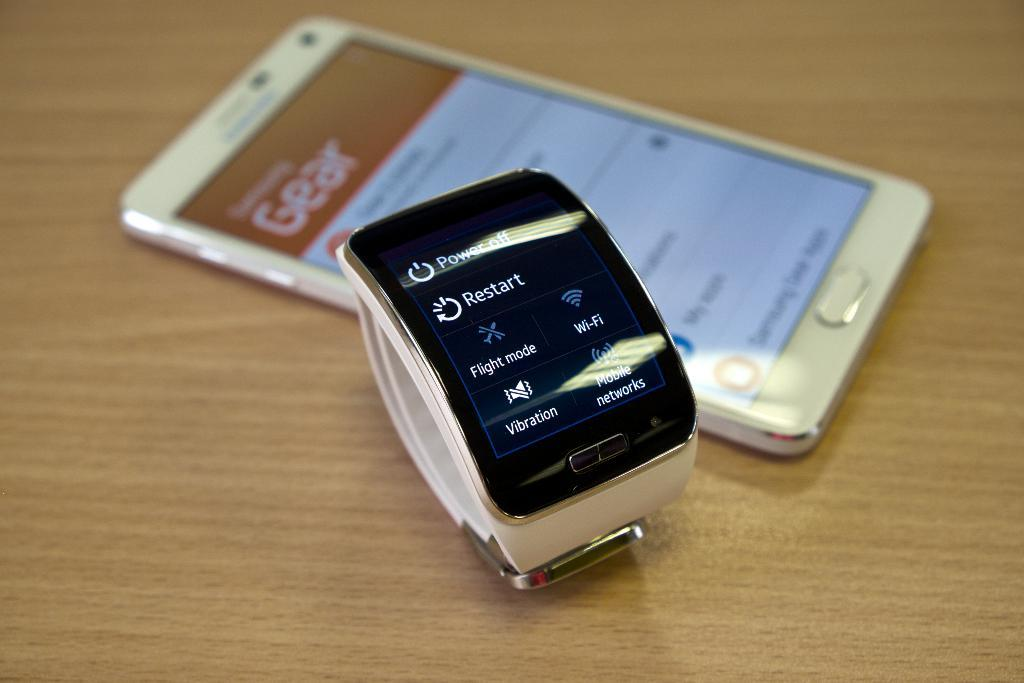<image>
Give a short and clear explanation of the subsequent image. A watch with the restart and power button on it. 